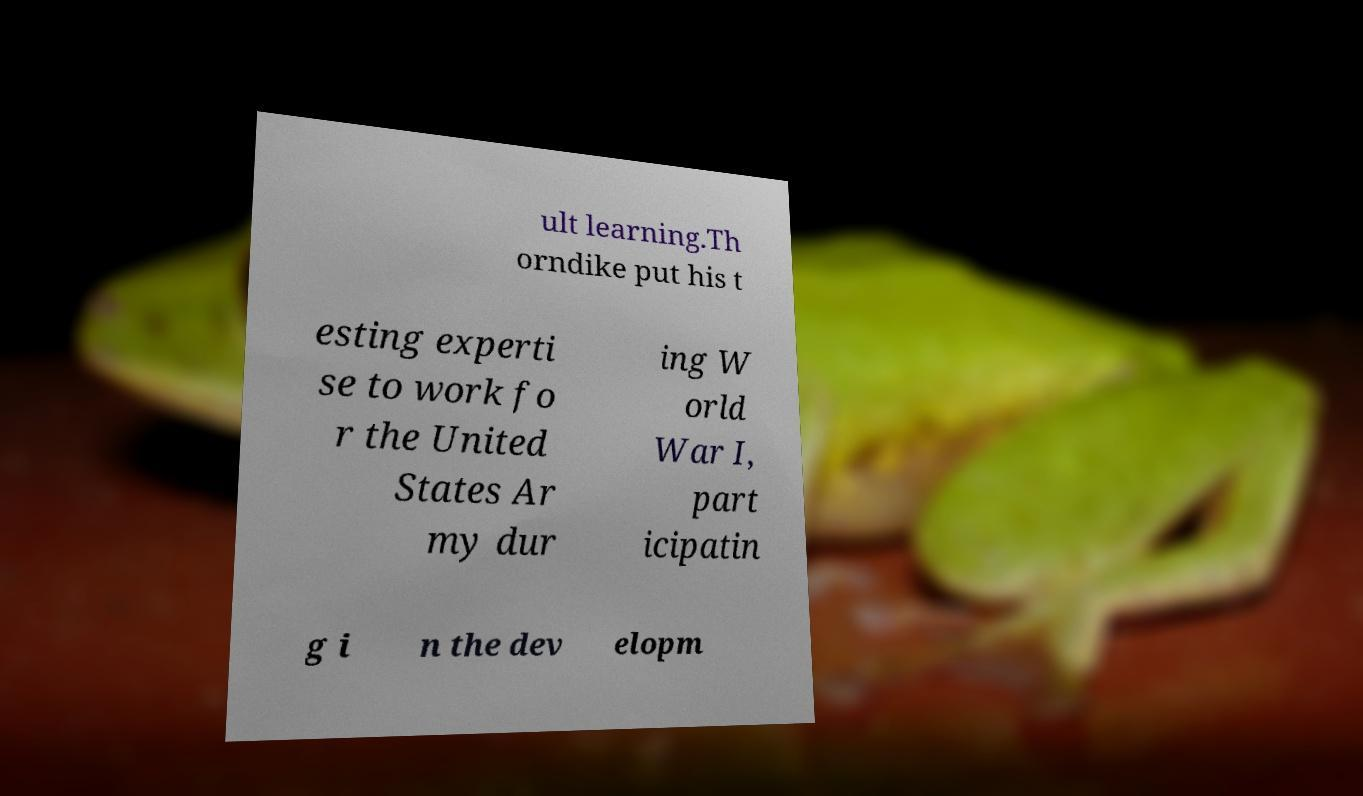Could you extract and type out the text from this image? ult learning.Th orndike put his t esting experti se to work fo r the United States Ar my dur ing W orld War I, part icipatin g i n the dev elopm 